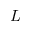<formula> <loc_0><loc_0><loc_500><loc_500>L</formula> 